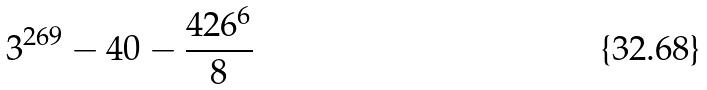Convert formula to latex. <formula><loc_0><loc_0><loc_500><loc_500>3 ^ { 2 6 9 } - 4 0 - \frac { 4 2 6 ^ { 6 } } { 8 }</formula> 